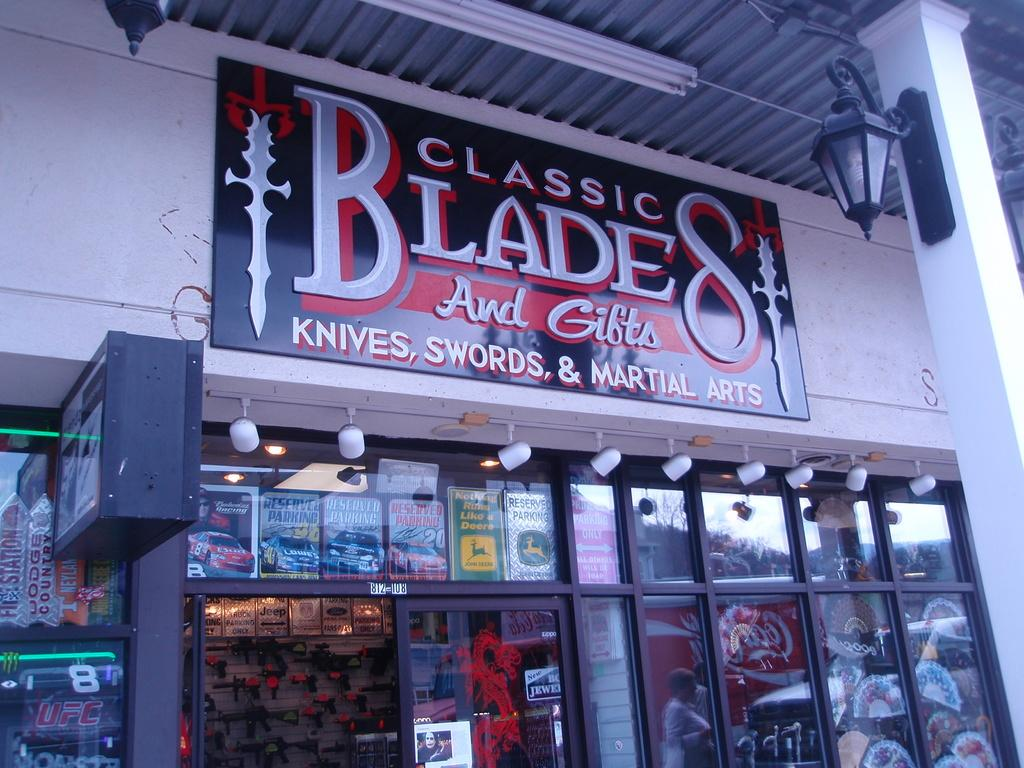<image>
Provide a brief description of the given image. Sharp implements of all kinds can be purchased at a store named Classic Blades. 